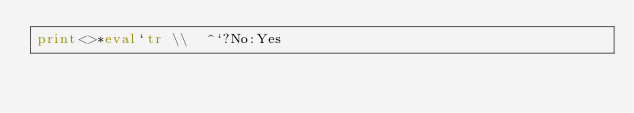Convert code to text. <code><loc_0><loc_0><loc_500><loc_500><_Perl_>print<>*eval`tr \\  ^`?No:Yes</code> 